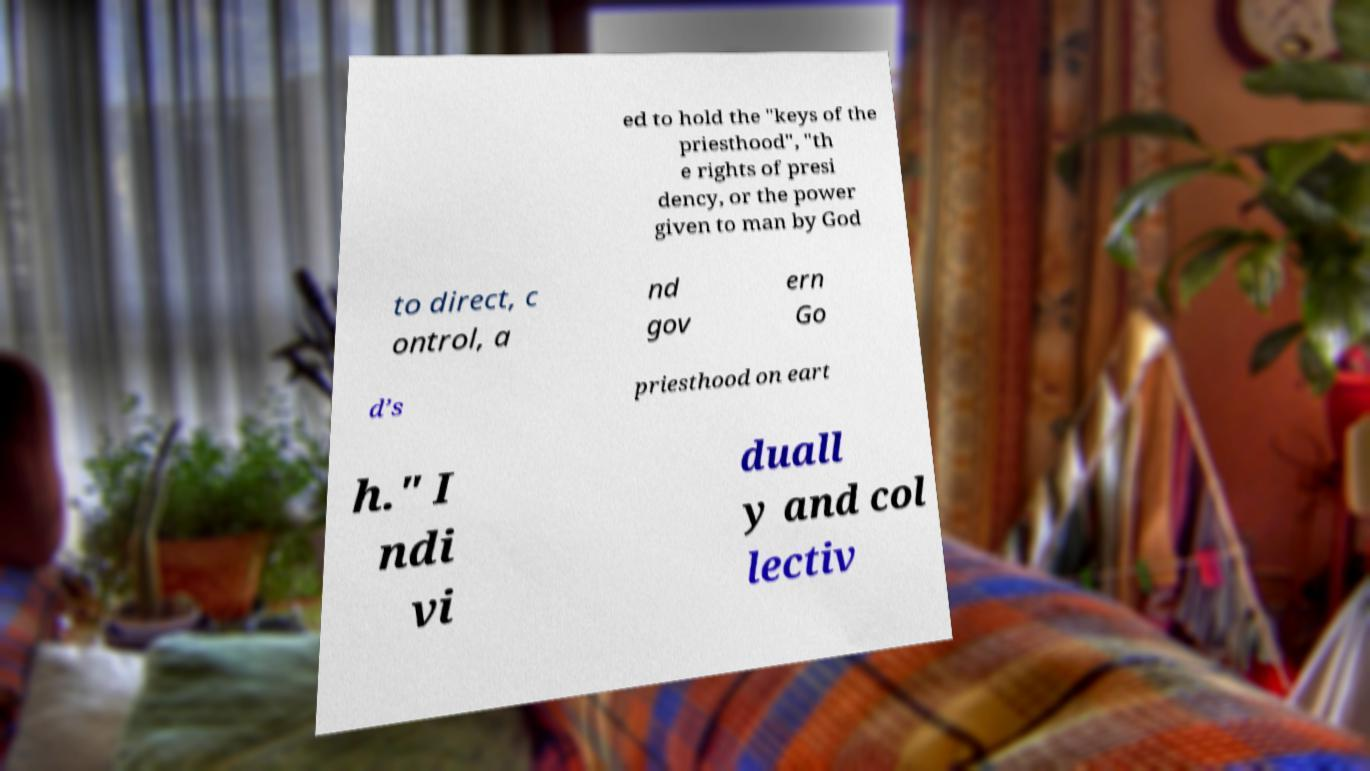Please identify and transcribe the text found in this image. ed to hold the "keys of the priesthood", "th e rights of presi dency, or the power given to man by God to direct, c ontrol, a nd gov ern Go d’s priesthood on eart h." I ndi vi duall y and col lectiv 